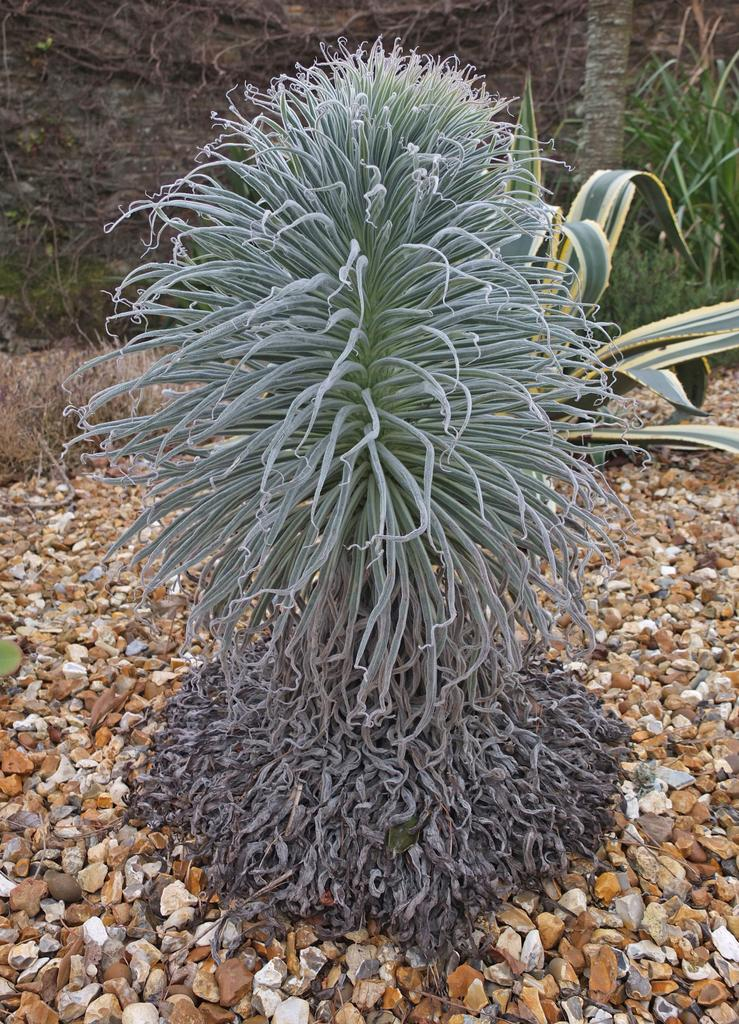What is the main subject in the front of the image? There is a plant in the front of the image. What can be seen around the plant? There are small stones around the plant. What is located on the top right side of the image? There are more plants and a tree trunk visible on the top right side of the image. What type of industry can be seen in the background of the image? There is no industry visible in the image; it primarily features plants and small stones. 